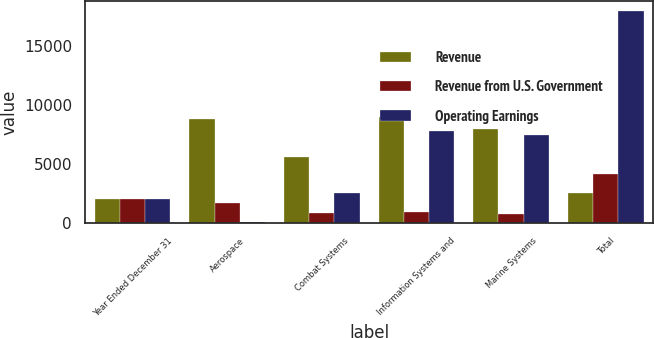<chart> <loc_0><loc_0><loc_500><loc_500><stacked_bar_chart><ecel><fcel>Year Ended December 31<fcel>Aerospace<fcel>Combat Systems<fcel>Information Systems and<fcel>Marine Systems<fcel>Total<nl><fcel>Revenue<fcel>2015<fcel>8851<fcel>5640<fcel>8965<fcel>8013<fcel>2583<nl><fcel>Revenue from U.S. Government<fcel>2015<fcel>1706<fcel>882<fcel>903<fcel>728<fcel>4178<nl><fcel>Operating Earnings<fcel>2015<fcel>104<fcel>2583<fcel>7856<fcel>7438<fcel>17981<nl></chart> 